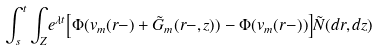<formula> <loc_0><loc_0><loc_500><loc_500>\int _ { s } ^ { t } \int _ { Z } & e ^ { \lambda t } \Big { [ } \Phi ( v _ { m } ( r - ) + \tilde { G } _ { m } ( r - , z ) ) - \Phi ( v _ { m } ( r - ) ) \Big { ] } \tilde { N } ( d r , d z )</formula> 